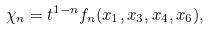Convert formula to latex. <formula><loc_0><loc_0><loc_500><loc_500>\chi _ { n } = t ^ { 1 - n } f _ { n } ( x _ { 1 } , x _ { 3 } , x _ { 4 } , x _ { 6 } ) ,</formula> 